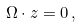Convert formula to latex. <formula><loc_0><loc_0><loc_500><loc_500>\Omega \cdot z = 0 \, ,</formula> 